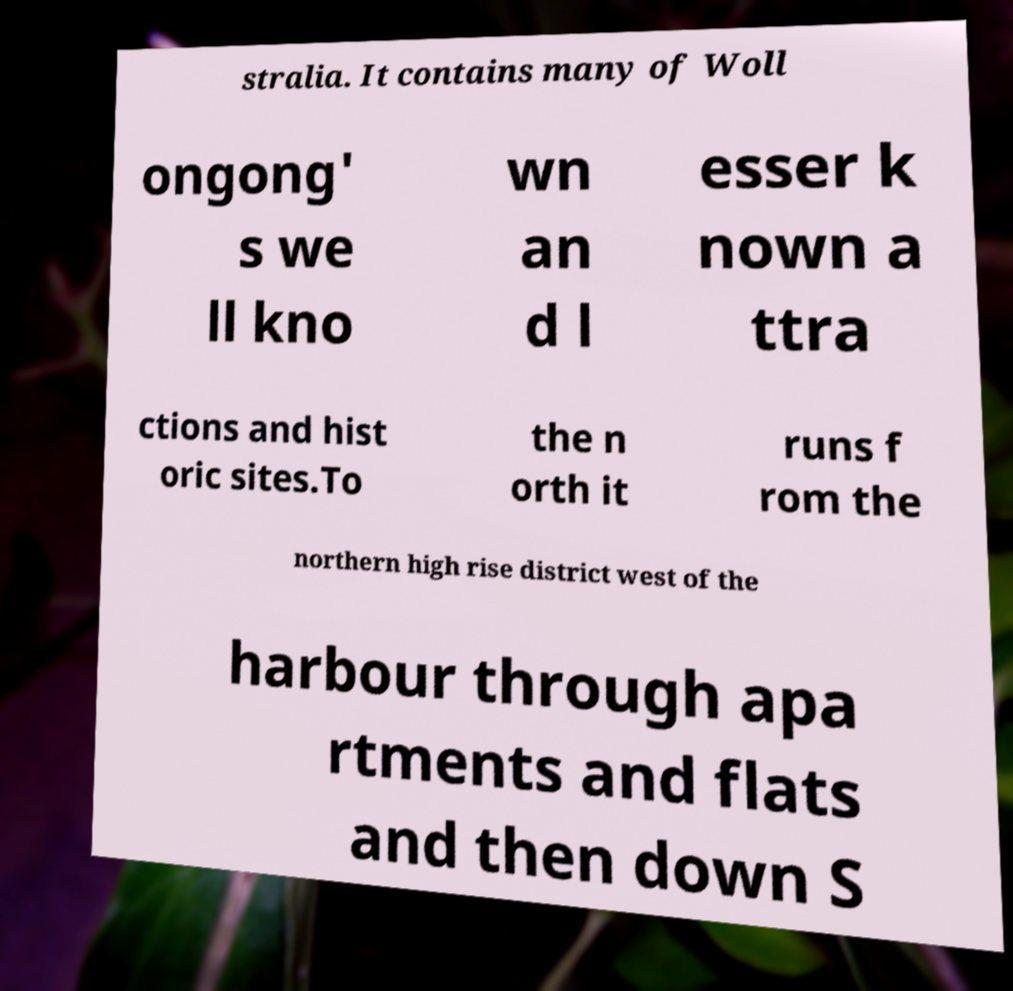Could you assist in decoding the text presented in this image and type it out clearly? stralia. It contains many of Woll ongong' s we ll kno wn an d l esser k nown a ttra ctions and hist oric sites.To the n orth it runs f rom the northern high rise district west of the harbour through apa rtments and flats and then down S 